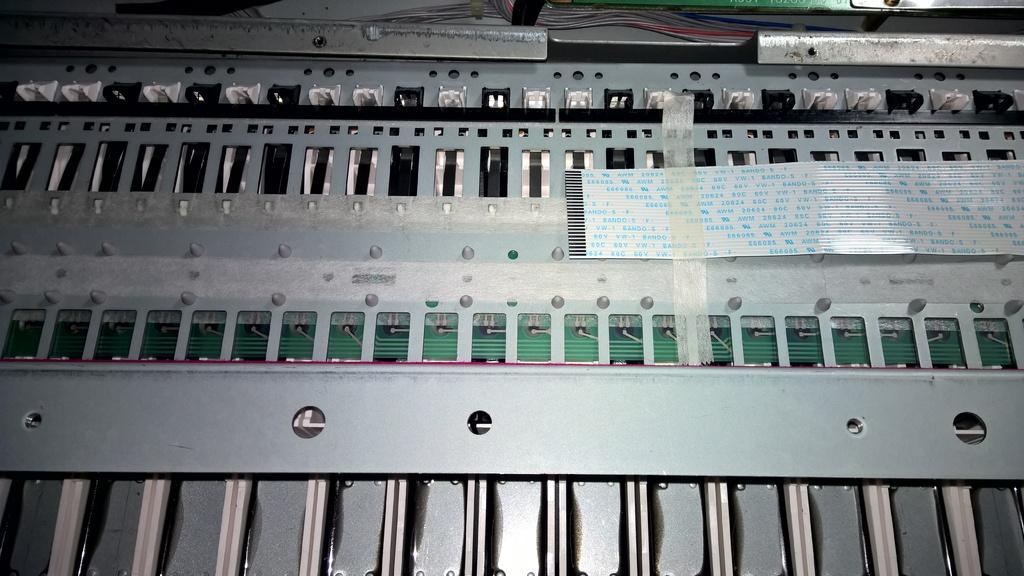How would you summarize this image in a sentence or two? In the middle of the image we can see some circuits. At the top of the image there are some key holes. Bottom of the image there is keys. 